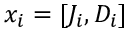<formula> <loc_0><loc_0><loc_500><loc_500>x _ { i } = [ J _ { i } , D _ { i } ]</formula> 